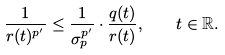<formula> <loc_0><loc_0><loc_500><loc_500>\frac { 1 } { r ( t ) ^ { p ^ { \prime } } } \leq \frac { 1 } { \sigma _ { p } ^ { p ^ { \prime } } } \cdot \frac { q ( t ) } { r ( t ) } , \quad t \in \mathbb { R } .</formula> 